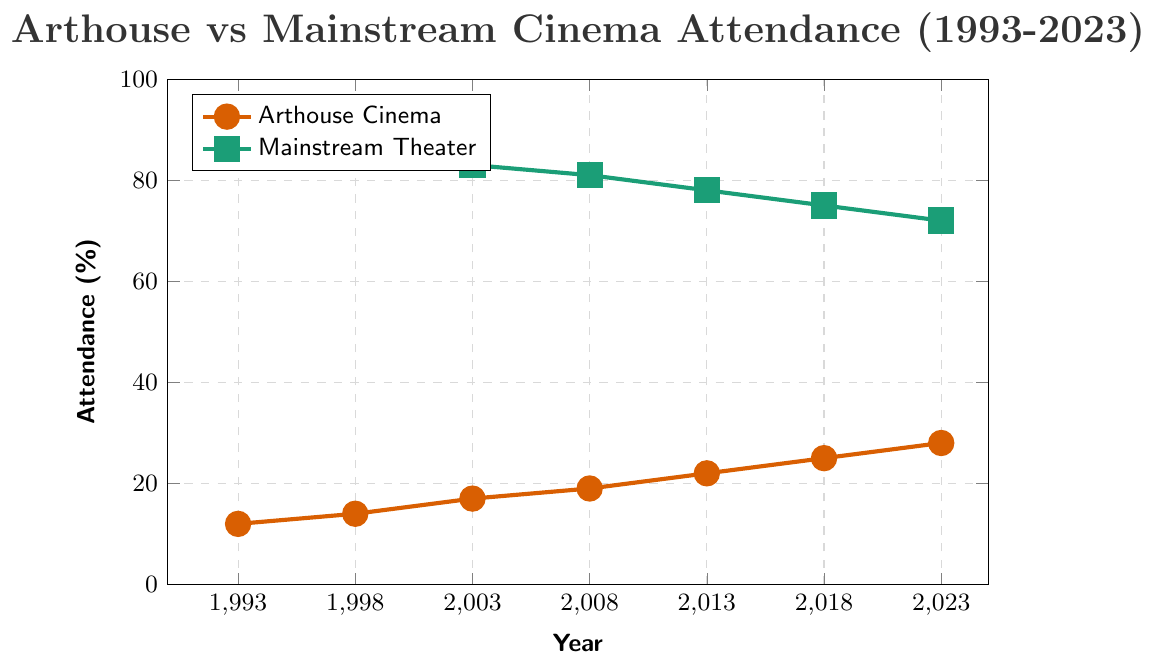What trend is observed for arthouse cinema attendance from 1993 to 2023? The attendance for arthouses increases consistently over the years. In 1993, it was at 12%, and it grows to 28% by 2023. This indicates a steady rise in interest in arthouse cinemas.
Answer: A consistent increase How does mainstream theater attendance change over the same period? The graph shows a steady decline in mainstream theater attendance. Starting from 88% in 1993, it gradually decreases to 72% by 2023.
Answer: A consistent decrease What's the difference in attendance between arthouse cinemas and mainstream theaters in 2023? In 2023, arthouse cinema attendance is at 28%, and mainstream theater attendance is at 72%. The difference is 72% - 28% = 44%.
Answer: 44% Which year shows the largest gap between arthouse and mainstream attendance, and what is the gap? To find the largest gap, observe the differences year by year: 1993 (76%), 1998 (72%), 2003 (66%), 2008 (62%), 2013 (56%), 2018 (50%), 2023 (44%). The largest gap occurs in 1993 with a 76% difference.
Answer: 1993, 76% Is there any year where arthouse cinema attendance is at least 20 percentage points higher than the previous year? By checking each pair of consecutive years: 1993-1998 (2%), 1998-2003 (3%), 2003-2008 (2%), 2008-2013 (3%), 2013-2018 (3%), 2018-2023 (3%). None of the increases are 20 percentage points or higher.
Answer: No What is the average annual attendance of arthouse cinemas over the 30 years? Add up the arthouse attendance values from each year (12 + 14 + 17 + 19 + 22 + 25 + 28 = 137), then divide by the number of years, which is 7. 137 / 7 = 19.57%.
Answer: 19.57% Which color represents arthouse cinema attendance in the plot, and which represents mainstream theater attendance? From the legend, arthouse cinema attendance is represented by the brownish-orange line, and mainstream theater attendance is represented by the green line.
Answer: Brownish-orange for arthouse, green for mainstream In which 5-year period does arthouse attendance grow the most? Calculate differences between the points: 1993-1998 (2%), 1998-2003 (3%), 2003-2008 (2%), 2008-2013 (3%), 2013-2018 (3%), 2018-2023 (3%). The periods 1998-2003, 2008-2013, 2013-2018, and 2018-2023 have the highest growth of 3%.
Answer: 1998-2003, 2008-2013, 2013-2018, 2018-2023 (3% growth each) By how much did mainstream theater attendance decrease from 2008 to 2013, and how does it compare to the decrease from 2018 to 2023? Mainstream attendance in 2008 is 81% and in 2013 is 78%, so it decreased by 3% (81% - 78%). From 2018 to 2023, it decreased from 75% to 72%, which is also a 3% decrease.
Answer: Both decreases were 3% Was there any year where both arthouse cinema and mainstream theater attendance changed by the same percentage? Compare the percentage changes: 1993-1998 (Arthouse +2%, Mainstream -2%), 1998-2003 (Arthouse +3%, Mainstream -3%), 2003-2008 (Arthouse +2%, Mainstream -2%), 2008-2013 (Arthouse +3%, Mainstream -3%), 2013-2018 (Arthouse +3%, Mainstream -3%), 2018-2023 (Arthouse +3%, Mainstream -3%). All years show equal but opposite percentage changes.
Answer: All years (opposite changes of same magnitude) 